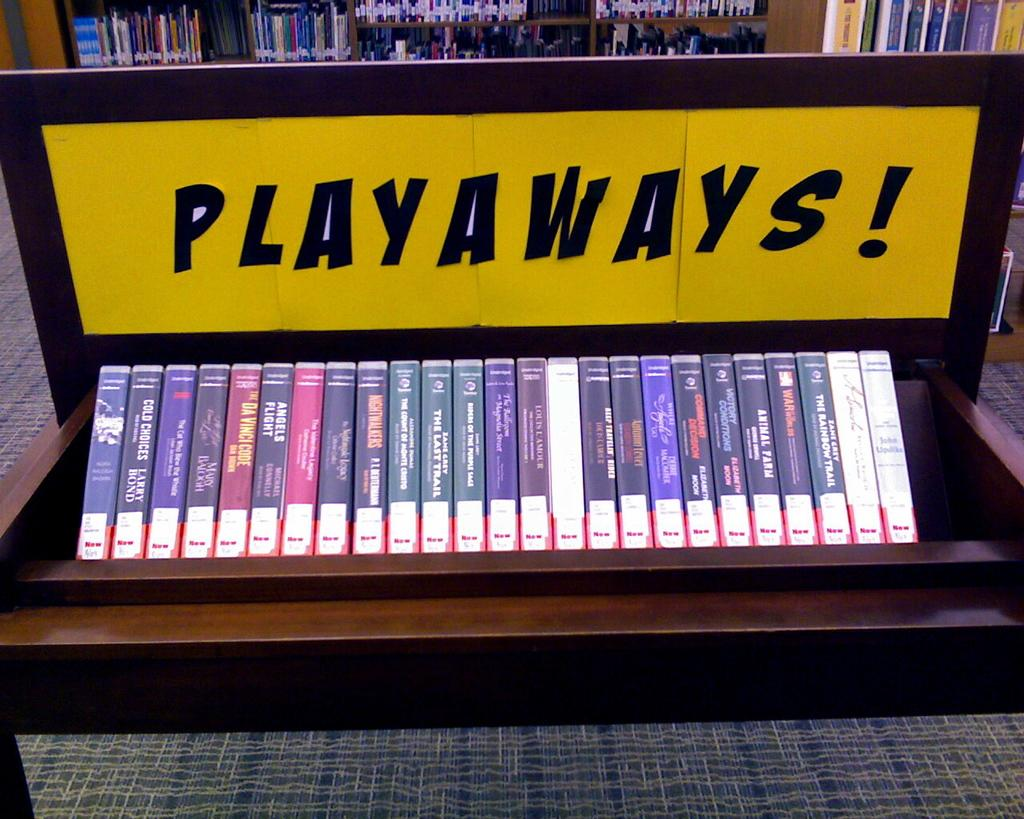Provide a one-sentence caption for the provided image. Promoting either books or videos is a yellow sign that reads PLAYAWAYS!. 